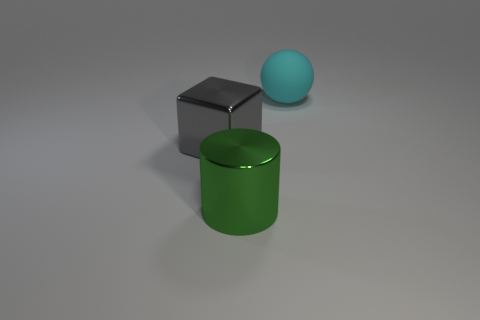Add 3 brown metal cylinders. How many objects exist? 6 Subtract all cylinders. How many objects are left? 2 Subtract all green metallic objects. Subtract all matte objects. How many objects are left? 1 Add 3 gray blocks. How many gray blocks are left? 4 Add 1 green spheres. How many green spheres exist? 1 Subtract 1 green cylinders. How many objects are left? 2 